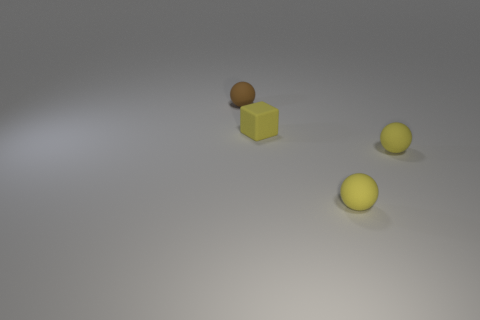How many things are matte spheres that are on the right side of the small brown thing or matte things that are behind the yellow block?
Provide a short and direct response. 3. What number of metal objects are large things or brown balls?
Provide a succinct answer. 0. There is a rubber sphere behind the small rubber cube; how many brown rubber objects are behind it?
Make the answer very short. 0. What is the color of the cube that is the same material as the tiny brown sphere?
Your answer should be very brief. Yellow. The brown rubber sphere has what size?
Make the answer very short. Small. What is the shape of the brown object that is made of the same material as the cube?
Offer a very short reply. Sphere. Are there fewer yellow matte cubes behind the yellow block than yellow rubber spheres?
Your answer should be compact. Yes. There is a matte sphere left of the tiny cube; what is its color?
Provide a succinct answer. Brown. Are there any purple matte objects that have the same shape as the small brown rubber thing?
Provide a short and direct response. No. How many other tiny things have the same shape as the brown object?
Your response must be concise. 2. 